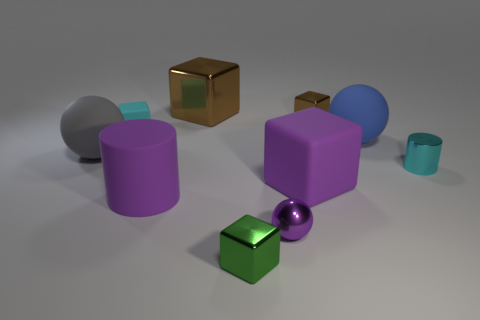Do the tiny brown thing and the tiny purple ball have the same material?
Offer a very short reply. Yes. Is the number of small red rubber spheres less than the number of big blue objects?
Keep it short and to the point. Yes. Is the shape of the big brown object the same as the small purple shiny object?
Your answer should be very brief. No. What is the color of the tiny sphere?
Ensure brevity in your answer.  Purple. How many other objects are there of the same material as the purple ball?
Your answer should be compact. 4. How many purple objects are small cylinders or small spheres?
Offer a very short reply. 1. There is a tiny metallic thing that is on the left side of the tiny ball; is it the same shape as the small metal object that is behind the cyan metal cylinder?
Your answer should be compact. Yes. There is a small shiny cylinder; is its color the same as the metal cube in front of the cyan cylinder?
Give a very brief answer. No. There is a shiny cube in front of the big gray sphere; is it the same color as the tiny sphere?
Offer a very short reply. No. How many things are either red matte cubes or tiny cyan objects that are on the left side of the tiny brown metal cube?
Keep it short and to the point. 1. 